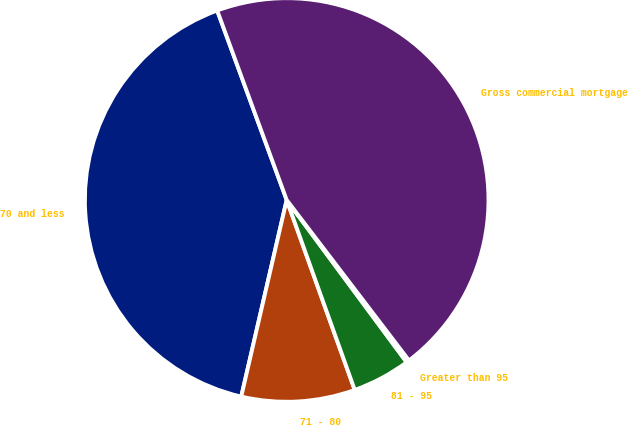Convert chart to OTSL. <chart><loc_0><loc_0><loc_500><loc_500><pie_chart><fcel>70 and less<fcel>71 - 80<fcel>81 - 95<fcel>Greater than 95<fcel>Gross commercial mortgage<nl><fcel>40.79%<fcel>9.09%<fcel>4.66%<fcel>0.23%<fcel>45.23%<nl></chart> 